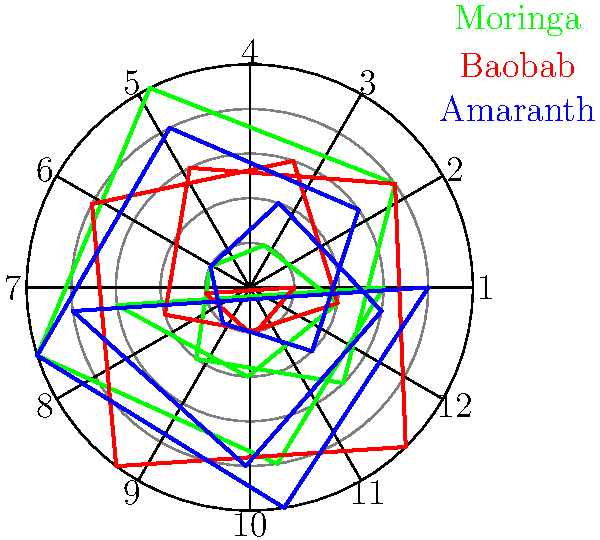Based on the polar graph showing the seasonal availability of three African plants used in traditional recipes, which plant has the highest availability during the 7th month (July) of the year? To determine which plant has the highest availability in July (7th month), we need to follow these steps:

1. Locate the 7th month on the polar graph. The months are numbered clockwise from 1 to 12, so the 7th month is in the lower right quadrant.

2. Identify the three plants represented on the graph:
   - Moringa (green line)
   - Baobab (red line)
   - Amaranth (blue line)

3. Compare the distance from the center for each plant's line at the 7th month:
   - Moringa: The green line is closest to the center, indicating low availability.
   - Baobab: The red line is farthest from the center, showing the highest availability.
   - Amaranth: The blue line is between Moringa and Baobab, indicating medium availability.

4. Based on the comparison, we can see that the red line (Baobab) extends the farthest from the center at the 7th month, indicating the highest availability.

Therefore, Baobab has the highest availability during the 7th month (July) of the year.
Answer: Baobab 